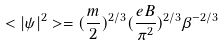<formula> <loc_0><loc_0><loc_500><loc_500>< | \psi | ^ { 2 } > = ( \frac { m } { 2 } ) ^ { 2 / 3 } ( \frac { e B } { \pi ^ { 2 } } ) ^ { 2 / 3 } \beta ^ { - 2 / 3 }</formula> 